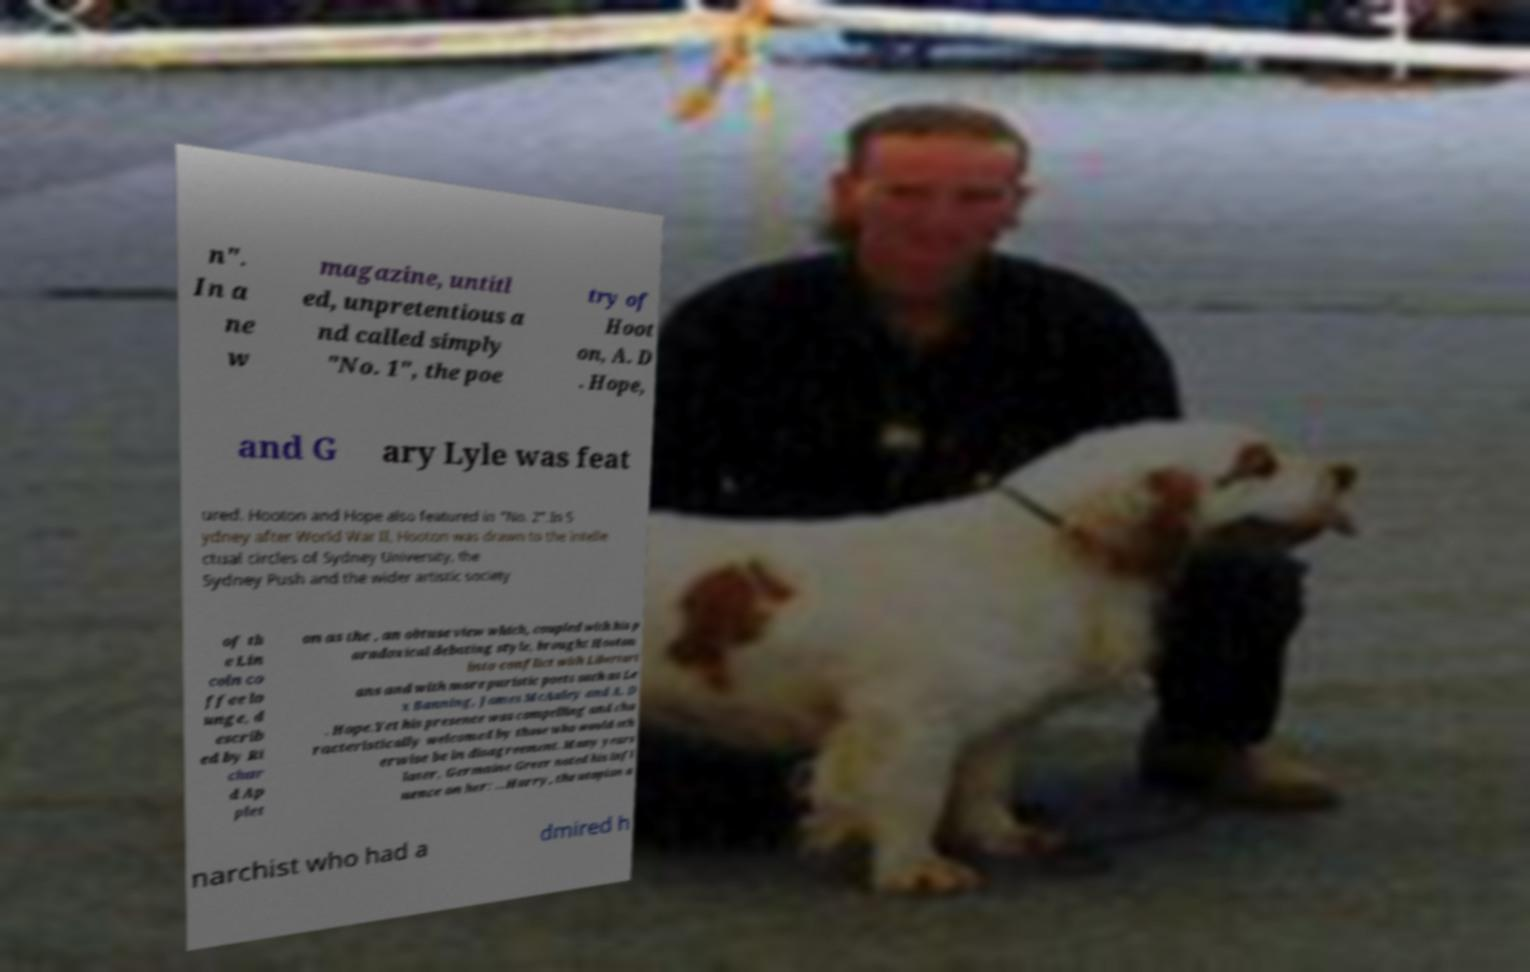Please identify and transcribe the text found in this image. n". In a ne w magazine, untitl ed, unpretentious a nd called simply "No. 1", the poe try of Hoot on, A. D . Hope, and G ary Lyle was feat ured. Hooton and Hope also featured in "No. 2".In S ydney after World War II, Hooton was drawn to the intelle ctual circles of Sydney University, the Sydney Push and the wider artistic society of th e Lin coln co ffee lo unge, d escrib ed by Ri char d Ap plet on as the , an obtuse view which, coupled with his p aradoxical debating style, brought Hooton into conflict with Libertari ans and with more puristic poets such as Le x Banning, James McAuley and A. D . Hope.Yet his presence was compelling and cha racteristically welcomed by those who would oth erwise be in disagreement. Many years later, Germaine Greer noted his infl uence on her: ...Harry, the utopian a narchist who had a dmired h 